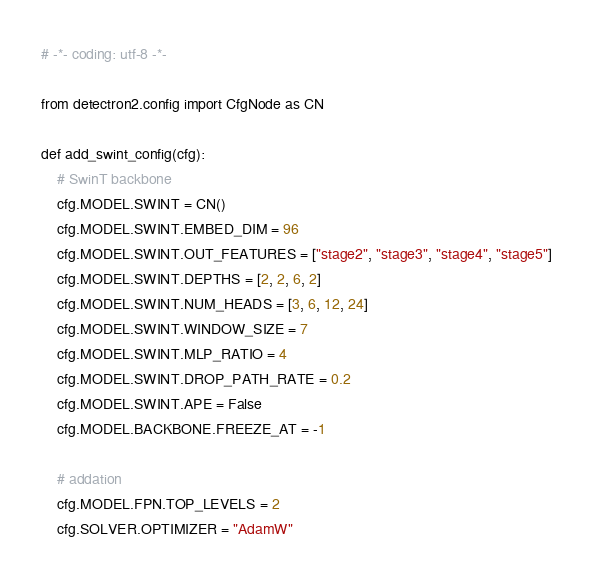Convert code to text. <code><loc_0><loc_0><loc_500><loc_500><_Python_># -*- coding: utf-8 -*-

from detectron2.config import CfgNode as CN

def add_swint_config(cfg):
    # SwinT backbone
    cfg.MODEL.SWINT = CN()
    cfg.MODEL.SWINT.EMBED_DIM = 96
    cfg.MODEL.SWINT.OUT_FEATURES = ["stage2", "stage3", "stage4", "stage5"]
    cfg.MODEL.SWINT.DEPTHS = [2, 2, 6, 2]
    cfg.MODEL.SWINT.NUM_HEADS = [3, 6, 12, 24]
    cfg.MODEL.SWINT.WINDOW_SIZE = 7
    cfg.MODEL.SWINT.MLP_RATIO = 4
    cfg.MODEL.SWINT.DROP_PATH_RATE = 0.2
    cfg.MODEL.SWINT.APE = False
    cfg.MODEL.BACKBONE.FREEZE_AT = -1

    # addation
    cfg.MODEL.FPN.TOP_LEVELS = 2
    cfg.SOLVER.OPTIMIZER = "AdamW"
</code> 